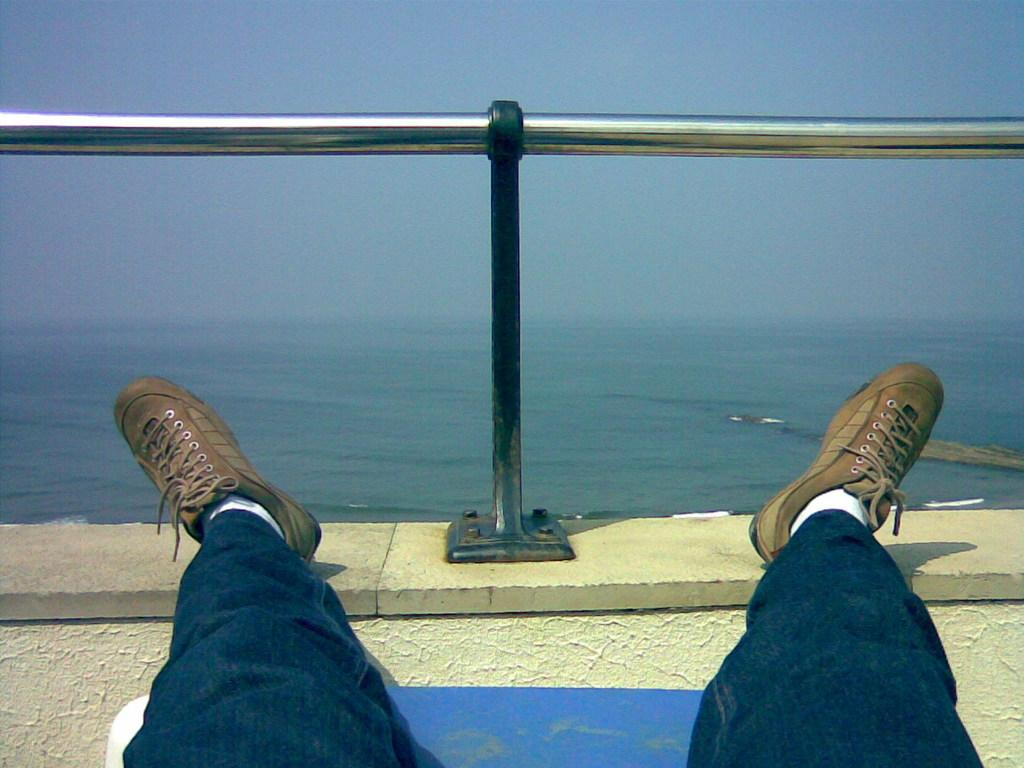What is the main setting of the image? The image depicts a sea. Can you describe the person in the image? There is a person sitting in the image. What type of structure is present in the image? There is a railing on a wall in the image. What natural element is visible in the image? Water is visible in the image. What is visible at the top of the image? The sky is visible at the top of the image. What type of cord is being used by the band in the image? There is no band or cord present in the image; it features a person sitting near a railing on a wall by the sea. 